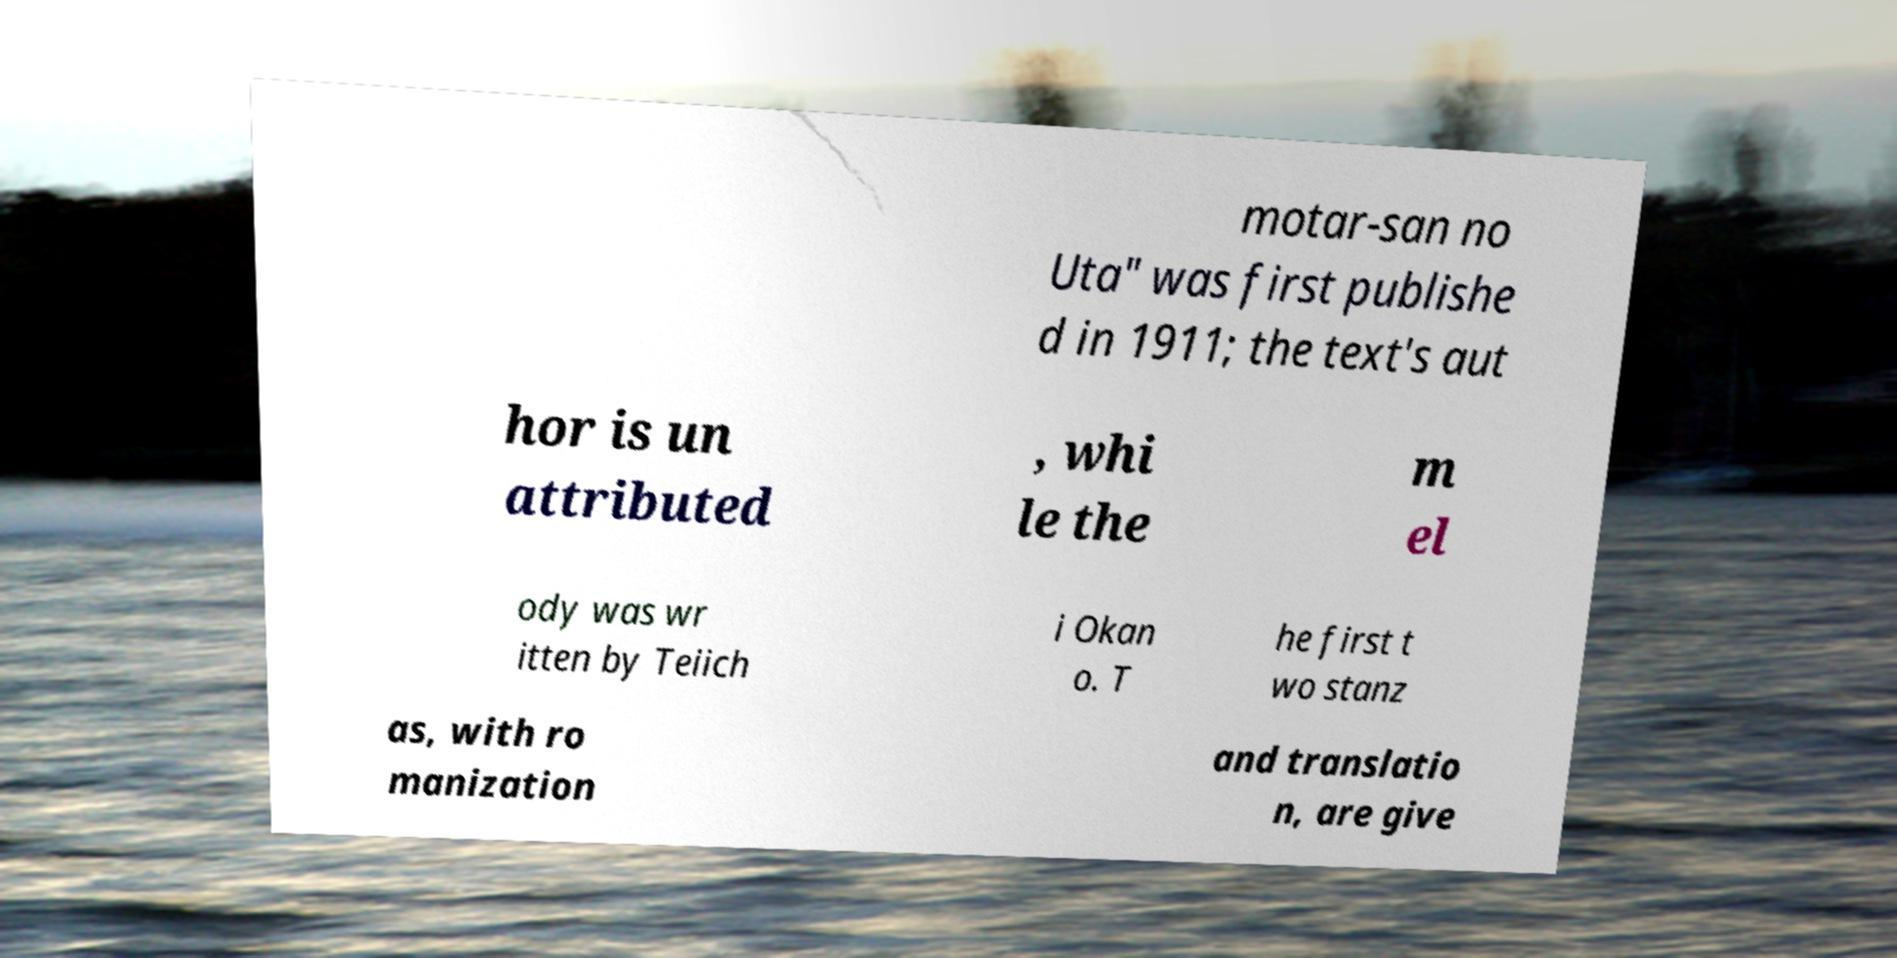Could you assist in decoding the text presented in this image and type it out clearly? motar-san no Uta" was first publishe d in 1911; the text's aut hor is un attributed , whi le the m el ody was wr itten by Teiich i Okan o. T he first t wo stanz as, with ro manization and translatio n, are give 